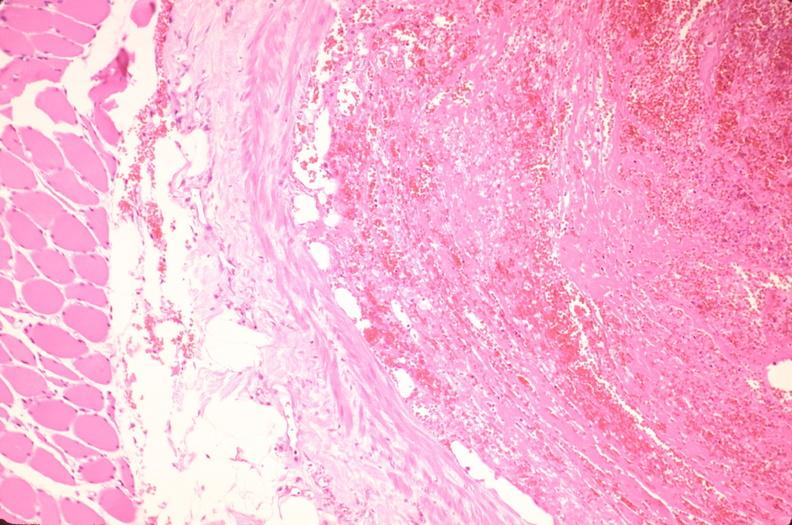does this image show thrombus in leg vein with early organization?
Answer the question using a single word or phrase. Yes 